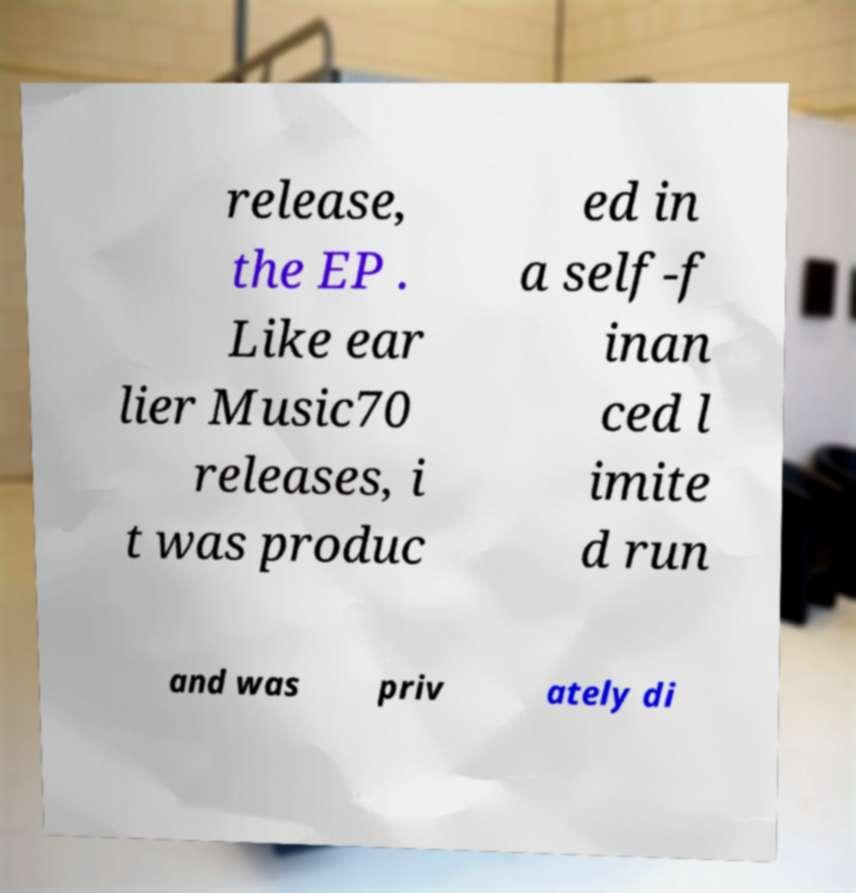Can you accurately transcribe the text from the provided image for me? release, the EP . Like ear lier Music70 releases, i t was produc ed in a self-f inan ced l imite d run and was priv ately di 